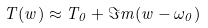Convert formula to latex. <formula><loc_0><loc_0><loc_500><loc_500>T ( w ) \approx T _ { 0 } + \Im m ( w - \omega _ { 0 } )</formula> 